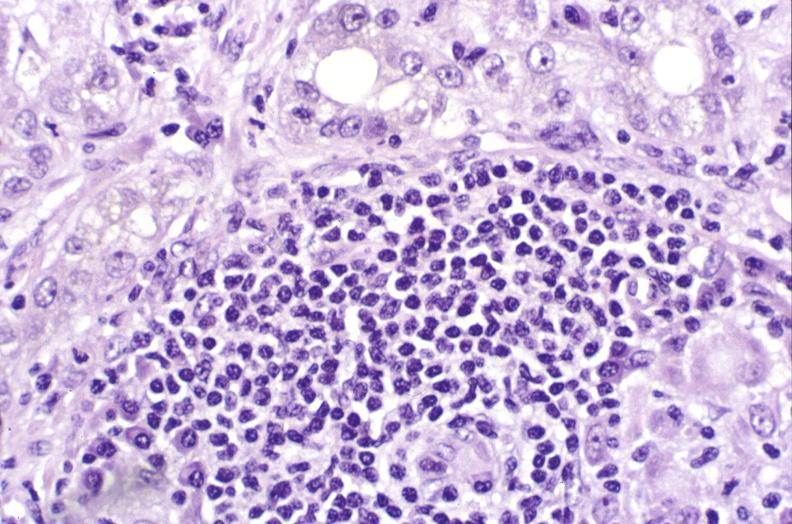does this image show primary biliary cirrhosis?
Answer the question using a single word or phrase. Yes 